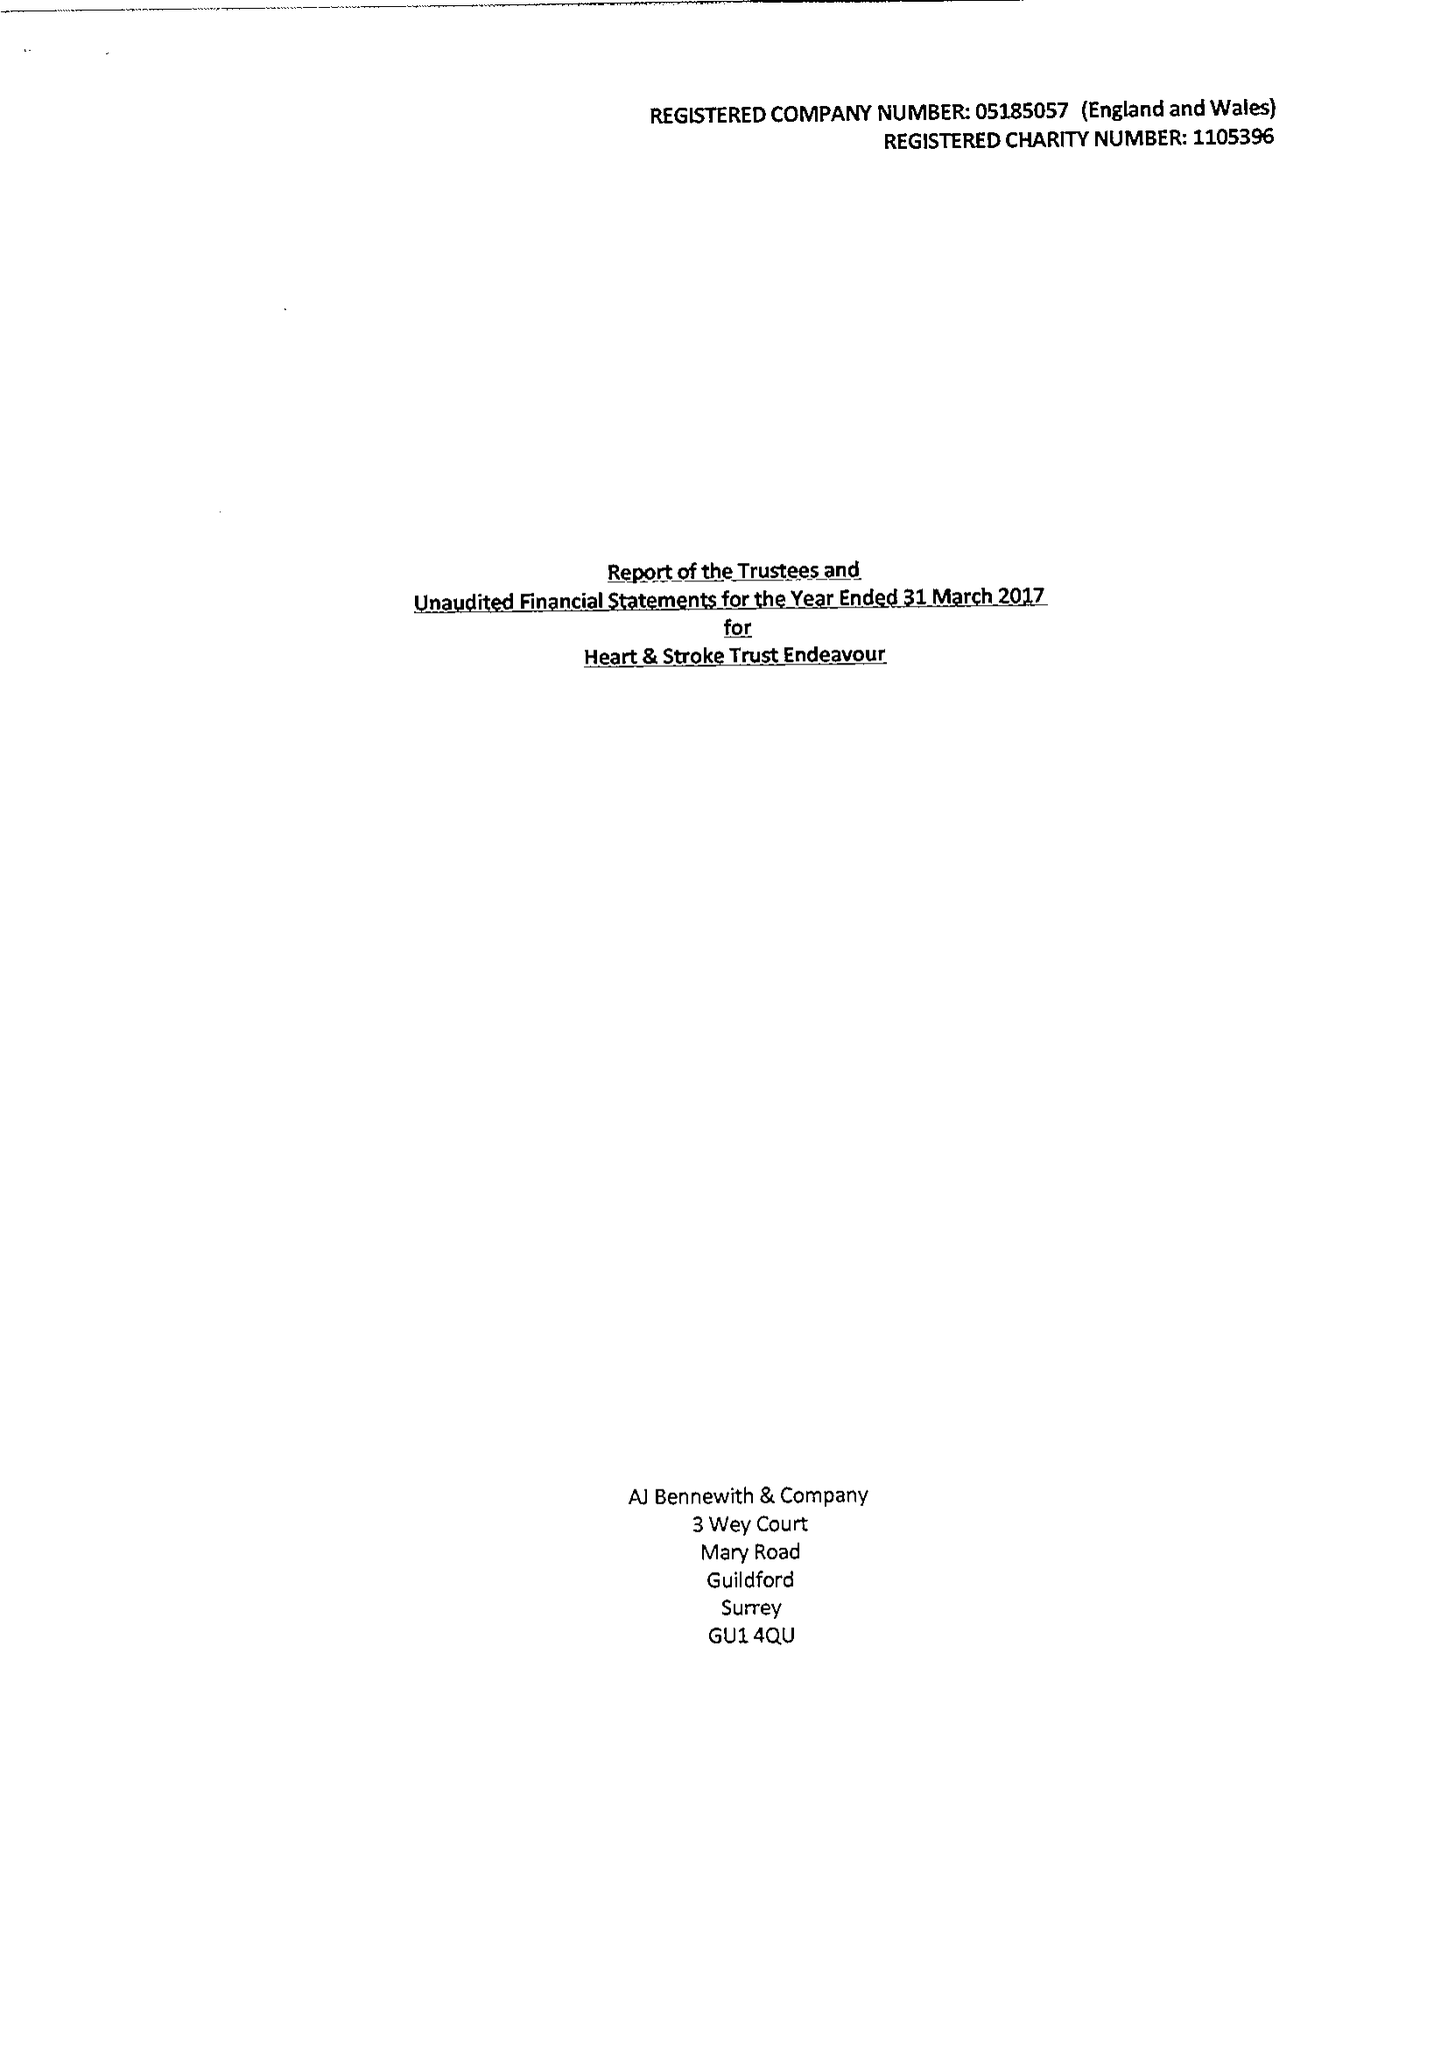What is the value for the income_annually_in_british_pounds?
Answer the question using a single word or phrase. 48784.00 